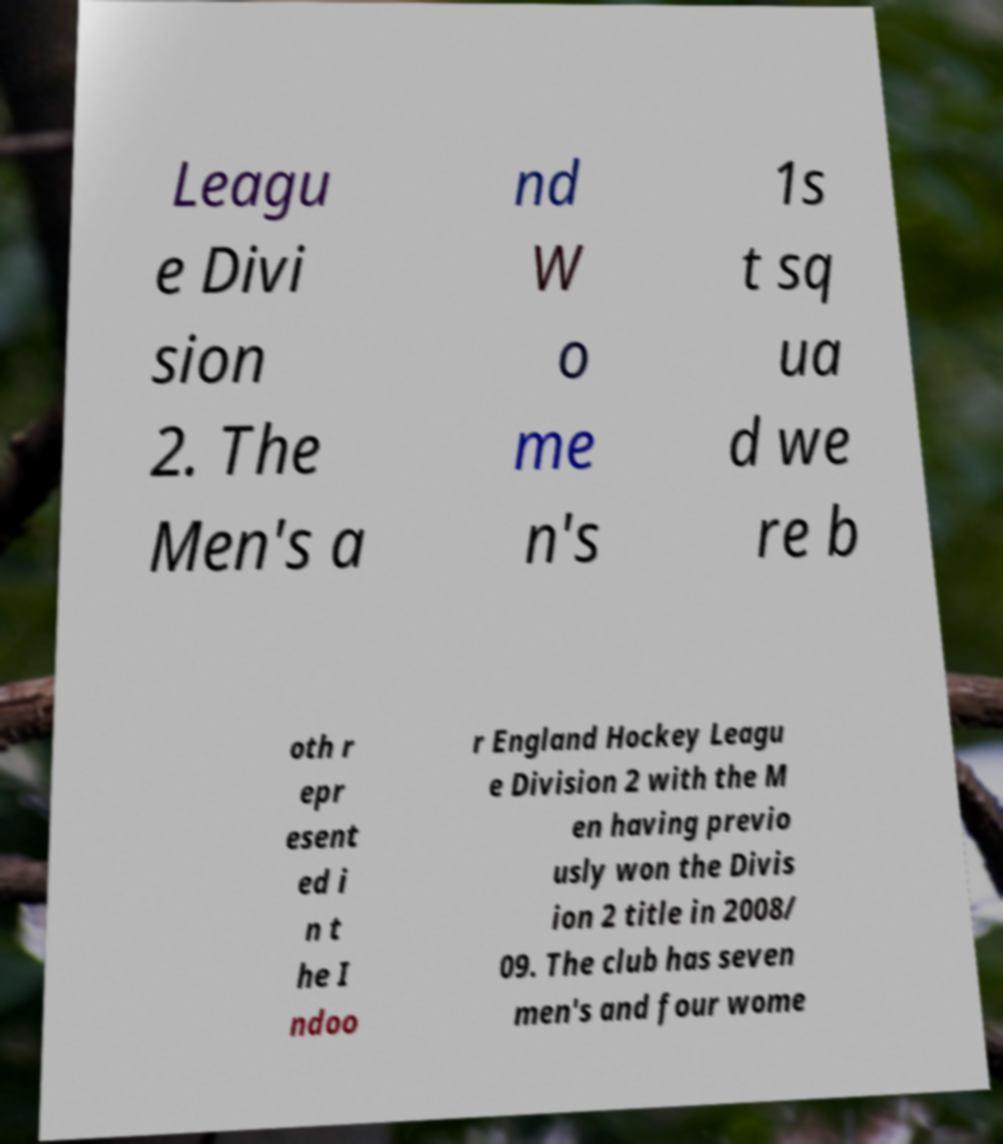Can you read and provide the text displayed in the image?This photo seems to have some interesting text. Can you extract and type it out for me? Leagu e Divi sion 2. The Men's a nd W o me n's 1s t sq ua d we re b oth r epr esent ed i n t he I ndoo r England Hockey Leagu e Division 2 with the M en having previo usly won the Divis ion 2 title in 2008/ 09. The club has seven men's and four wome 